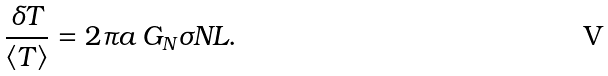Convert formula to latex. <formula><loc_0><loc_0><loc_500><loc_500>\frac { \delta T } { \langle T \rangle } = 2 \pi a \, G _ { N } \sigma N L .</formula> 